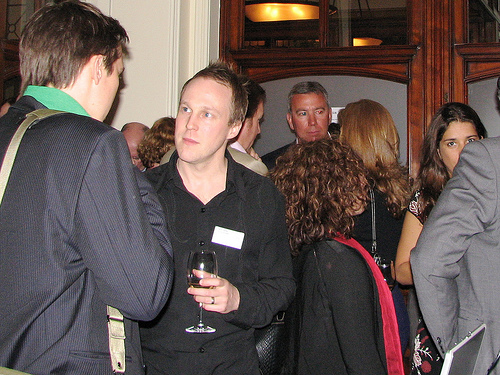<image>
Can you confirm if the girl is next to the man? Yes. The girl is positioned adjacent to the man, located nearby in the same general area. 